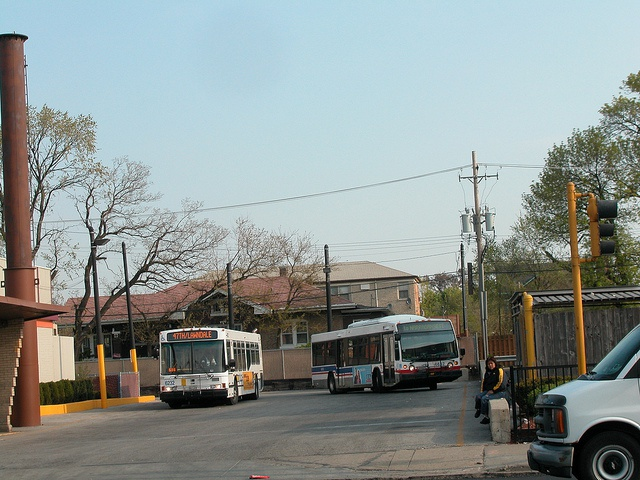Describe the objects in this image and their specific colors. I can see truck in lightblue, black, darkgray, gray, and teal tones, bus in lightblue, black, gray, darkgray, and maroon tones, bus in lightblue, gray, black, darkgray, and lightgray tones, traffic light in lightblue, black, maroon, and gray tones, and people in lightblue, black, gray, purple, and maroon tones in this image. 